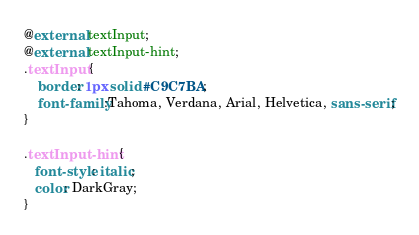Convert code to text. <code><loc_0><loc_0><loc_500><loc_500><_CSS_>@external textInput;
@external textInput-hint;
.textInput {
	border: 1px solid #C9C7BA;
	font-family:Tahoma, Verdana, Arial, Helvetica, sans-serif;
}

.textInput-hint {
   font-style: italic;
   color: DarkGray;
}
</code> 